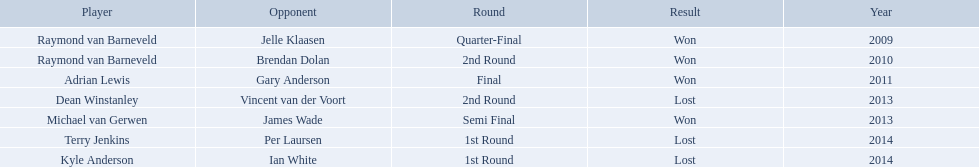What players competed in the pdc world darts championship? Raymond van Barneveld, Raymond van Barneveld, Adrian Lewis, Dean Winstanley, Michael van Gerwen, Terry Jenkins, Kyle Anderson. Of these players, who lost? Dean Winstanley, Terry Jenkins, Kyle Anderson. Which of these players lost in 2014? Terry Jenkins, Kyle Anderson. What are the players other than kyle anderson? Terry Jenkins. 